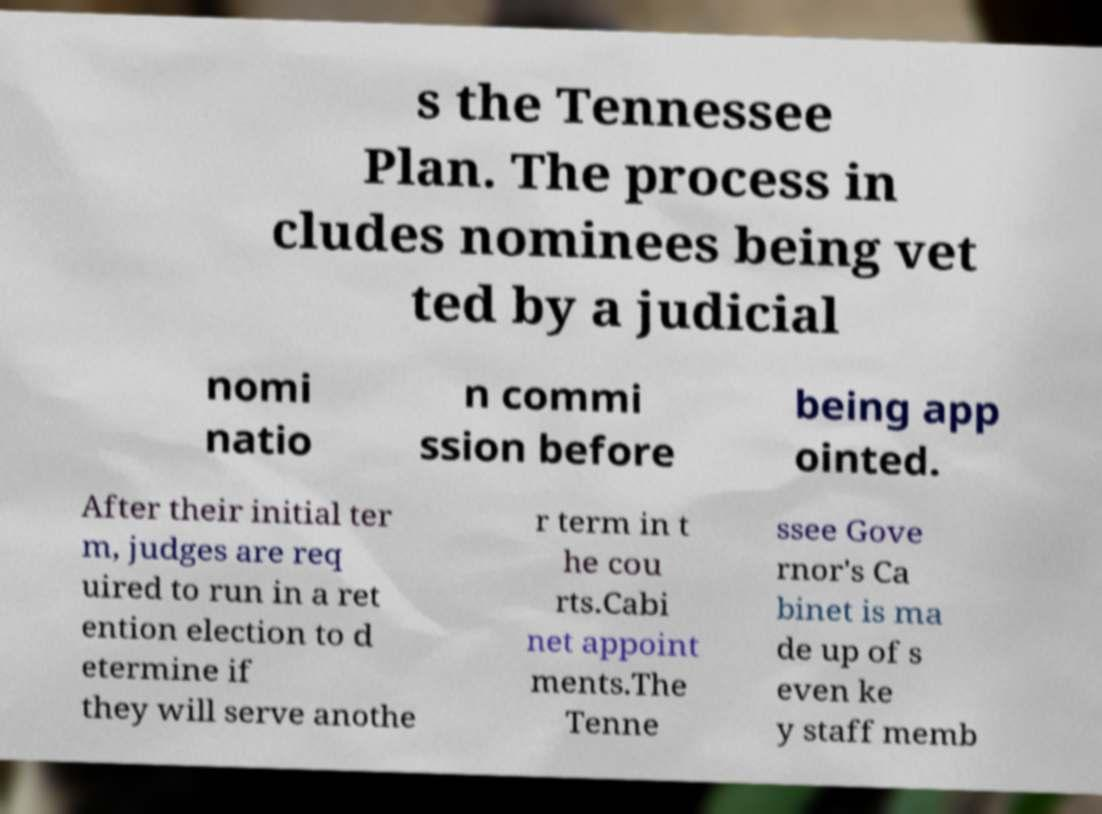I need the written content from this picture converted into text. Can you do that? s the Tennessee Plan. The process in cludes nominees being vet ted by a judicial nomi natio n commi ssion before being app ointed. After their initial ter m, judges are req uired to run in a ret ention election to d etermine if they will serve anothe r term in t he cou rts.Cabi net appoint ments.The Tenne ssee Gove rnor's Ca binet is ma de up of s even ke y staff memb 